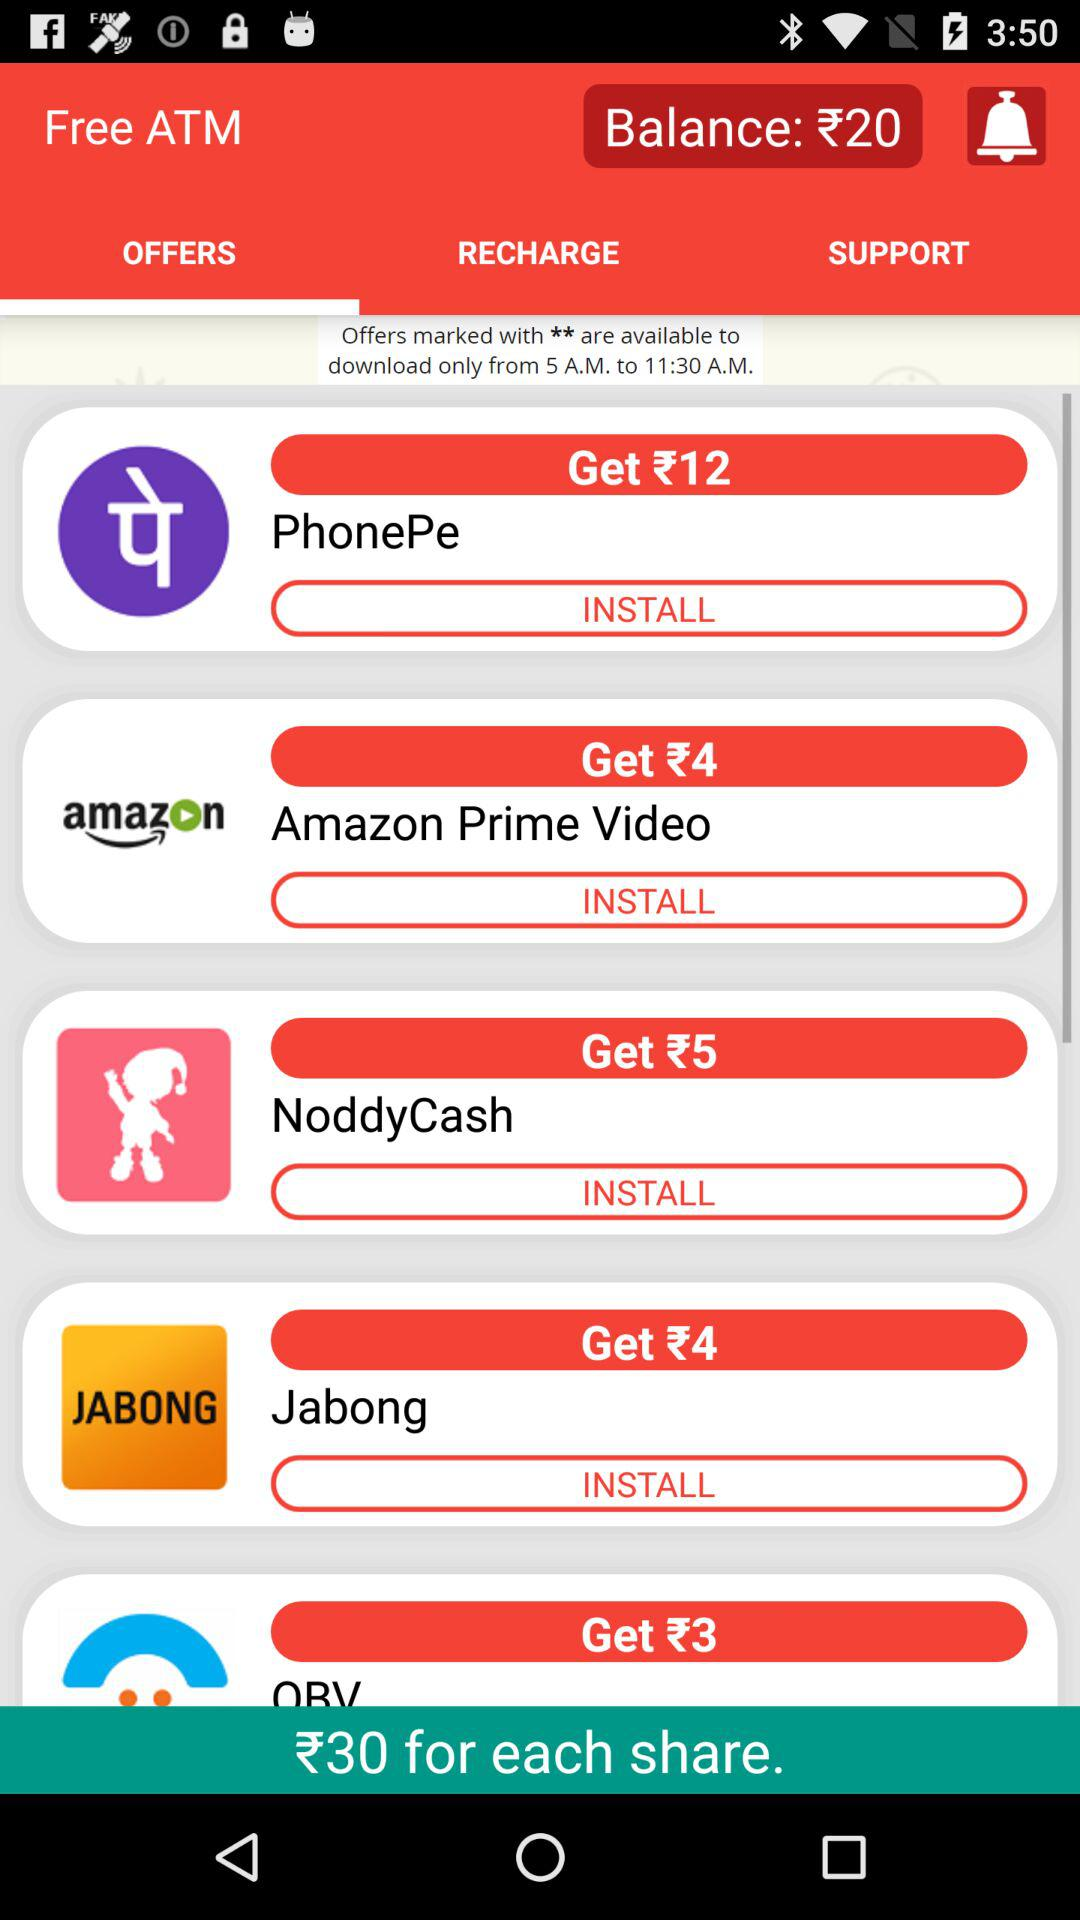How much balance is there in this? There is ₹20 in this balance. 